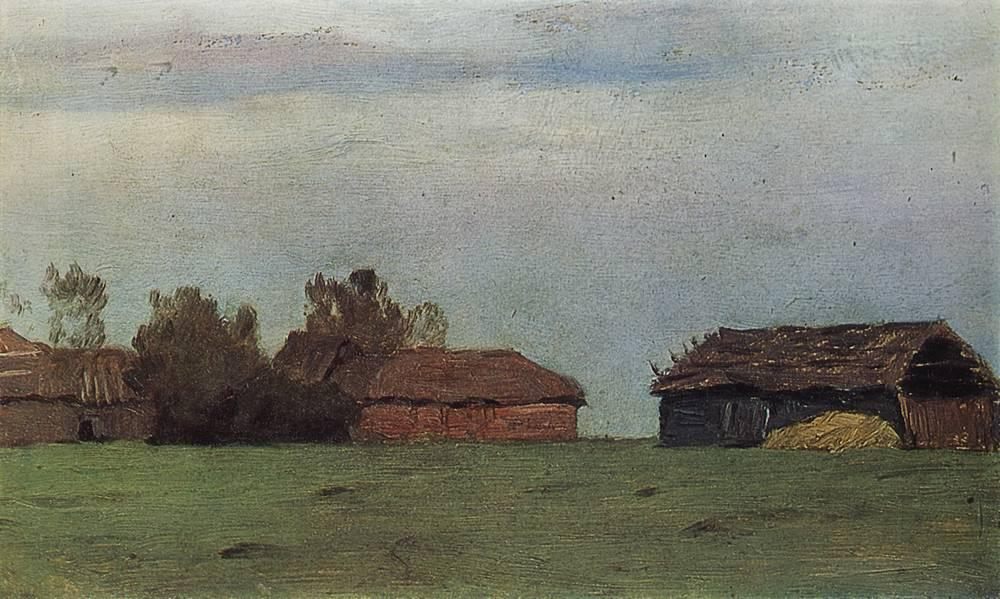Can we determine the season shown in the painting? The season in the painting could likely be either spring or early fall, judging by the fresh greenery of the grass and the absence of leaves on some of the trees, suggesting transition. 